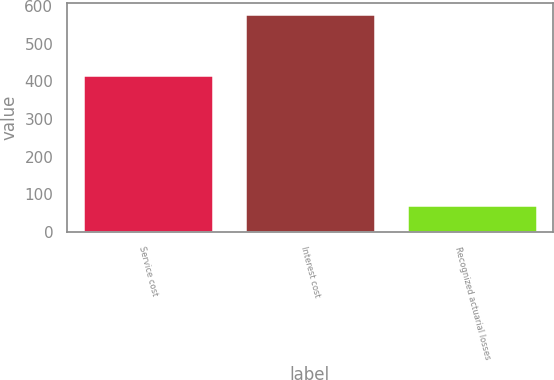<chart> <loc_0><loc_0><loc_500><loc_500><bar_chart><fcel>Service cost<fcel>Interest cost<fcel>Recognized actuarial losses<nl><fcel>417<fcel>579<fcel>72<nl></chart> 